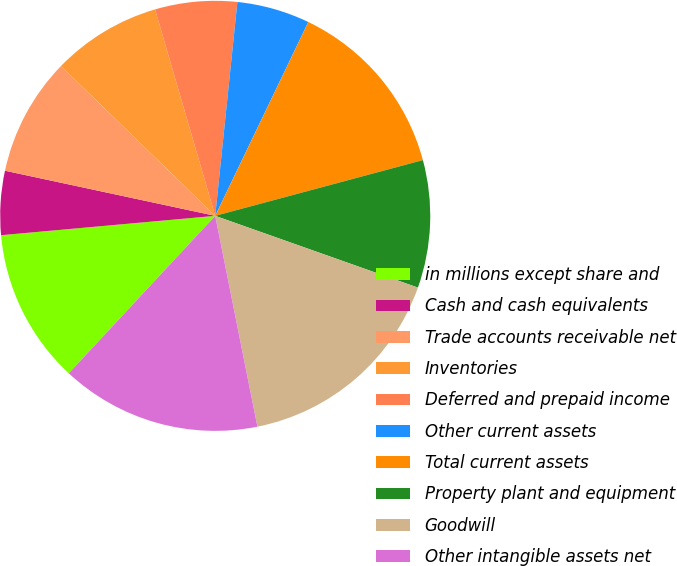<chart> <loc_0><loc_0><loc_500><loc_500><pie_chart><fcel>in millions except share and<fcel>Cash and cash equivalents<fcel>Trade accounts receivable net<fcel>Inventories<fcel>Deferred and prepaid income<fcel>Other current assets<fcel>Total current assets<fcel>Property plant and equipment<fcel>Goodwill<fcel>Other intangible assets net<nl><fcel>11.64%<fcel>4.8%<fcel>8.9%<fcel>8.22%<fcel>6.16%<fcel>5.48%<fcel>13.7%<fcel>9.59%<fcel>16.44%<fcel>15.07%<nl></chart> 